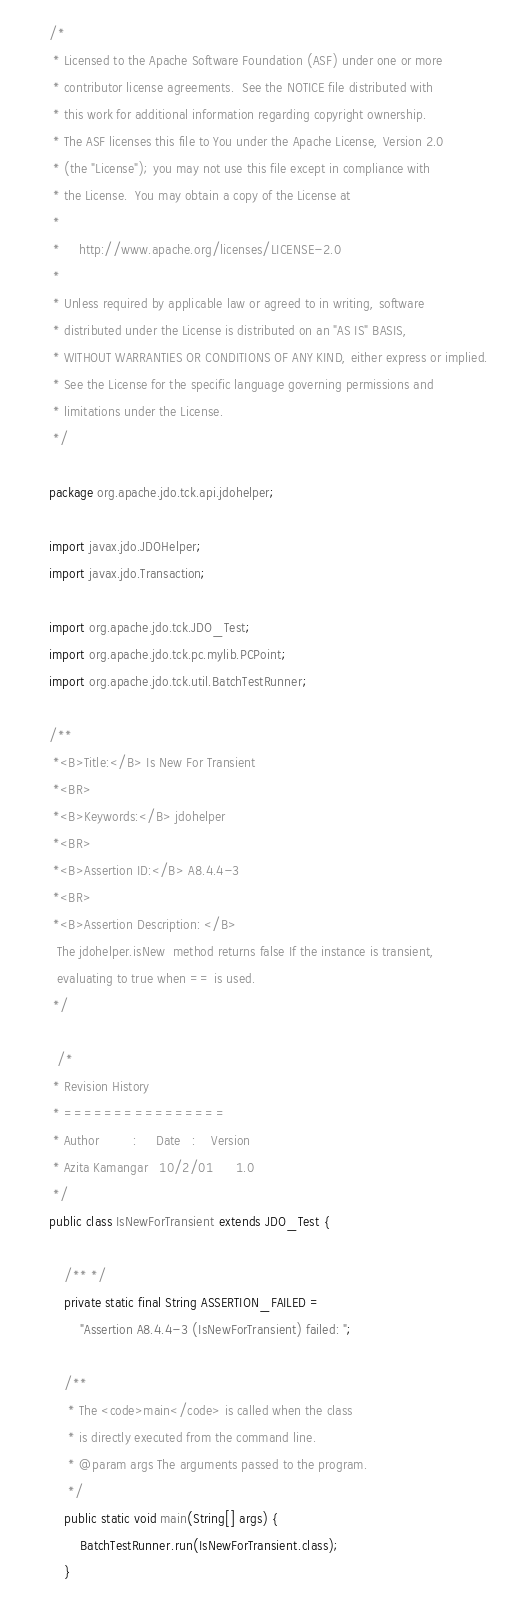Convert code to text. <code><loc_0><loc_0><loc_500><loc_500><_Java_>/*
 * Licensed to the Apache Software Foundation (ASF) under one or more
 * contributor license agreements.  See the NOTICE file distributed with
 * this work for additional information regarding copyright ownership.
 * The ASF licenses this file to You under the Apache License, Version 2.0
 * (the "License"); you may not use this file except in compliance with
 * the License.  You may obtain a copy of the License at
 * 
 *     http://www.apache.org/licenses/LICENSE-2.0
 * 
 * Unless required by applicable law or agreed to in writing, software 
 * distributed under the License is distributed on an "AS IS" BASIS, 
 * WITHOUT WARRANTIES OR CONDITIONS OF ANY KIND, either express or implied. 
 * See the License for the specific language governing permissions and 
 * limitations under the License.
 */
 
package org.apache.jdo.tck.api.jdohelper;

import javax.jdo.JDOHelper;
import javax.jdo.Transaction;

import org.apache.jdo.tck.JDO_Test;
import org.apache.jdo.tck.pc.mylib.PCPoint;
import org.apache.jdo.tck.util.BatchTestRunner;

/**
 *<B>Title:</B> Is New For Transient
 *<BR>
 *<B>Keywords:</B> jdohelper 
 *<BR>
 *<B>Assertion ID:</B> A8.4.4-3
 *<BR>
 *<B>Assertion Description: </B>
  The jdohelper.isNew  method returns false If the instance is transient,  
  evaluating to true when == is used. 
 */
  
  /*
 * Revision History
 * ================
 * Author         :   	Date   : 	Version  
 * Azita Kamangar  	10/2/01		 1.0
 */
public class IsNewForTransient extends JDO_Test {

    /** */
    private static final String ASSERTION_FAILED = 
        "Assertion A8.4.4-3 (IsNewForTransient) failed: ";
    
    /**
     * The <code>main</code> is called when the class
     * is directly executed from the command line.
     * @param args The arguments passed to the program.
     */
    public static void main(String[] args) {
        BatchTestRunner.run(IsNewForTransient.class);
    }
</code> 